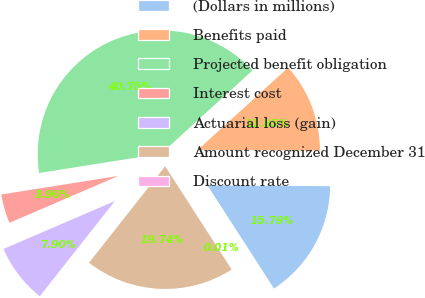<chart> <loc_0><loc_0><loc_500><loc_500><pie_chart><fcel>(Dollars in millions)<fcel>Benefits paid<fcel>Projected benefit obligation<fcel>Interest cost<fcel>Actuarial loss (gain)<fcel>Amount recognized December 31<fcel>Discount rate<nl><fcel>15.79%<fcel>11.85%<fcel>40.75%<fcel>3.96%<fcel>7.9%<fcel>19.74%<fcel>0.01%<nl></chart> 